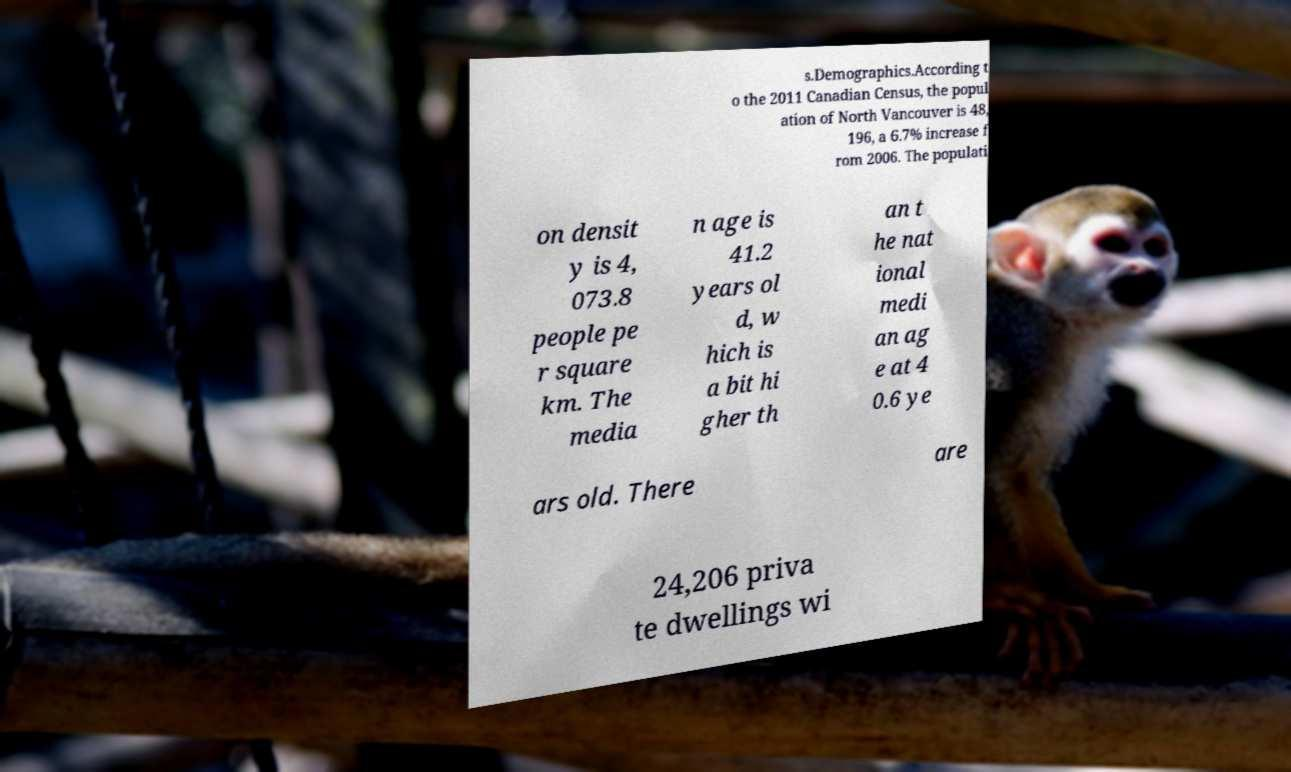Can you accurately transcribe the text from the provided image for me? s.Demographics.According t o the 2011 Canadian Census, the popul ation of North Vancouver is 48, 196, a 6.7% increase f rom 2006. The populati on densit y is 4, 073.8 people pe r square km. The media n age is 41.2 years ol d, w hich is a bit hi gher th an t he nat ional medi an ag e at 4 0.6 ye ars old. There are 24,206 priva te dwellings wi 